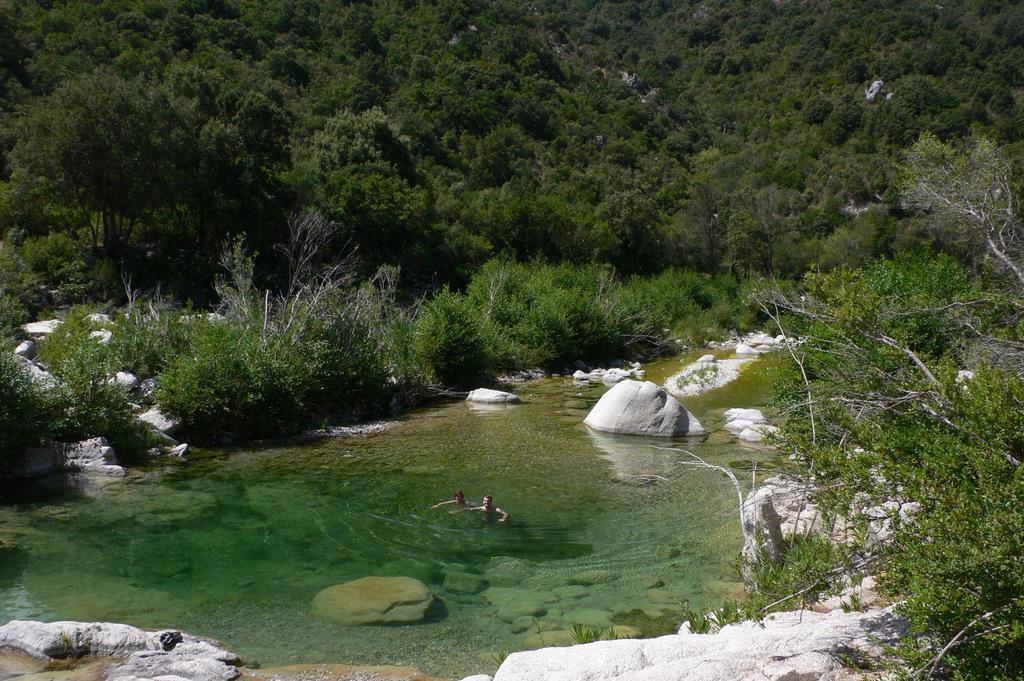Describe this image in one or two sentences. In the foreground of this image, there are stones and trees. In the middle, there are two persons in the water. In the background, there is greenery. 